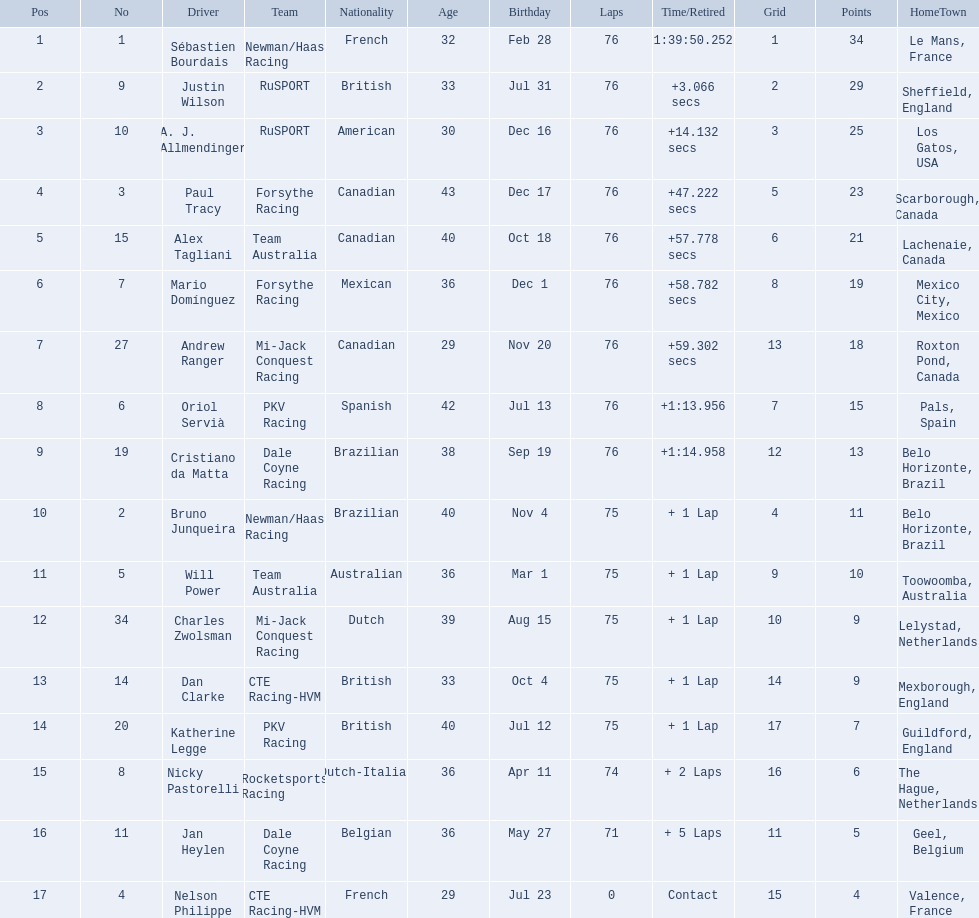Is there a driver named charles zwolsman? Charles Zwolsman. How many points did he acquire? 9. Were there any other entries that got the same number of points? 9. Who did that entry belong to? Dan Clarke. 